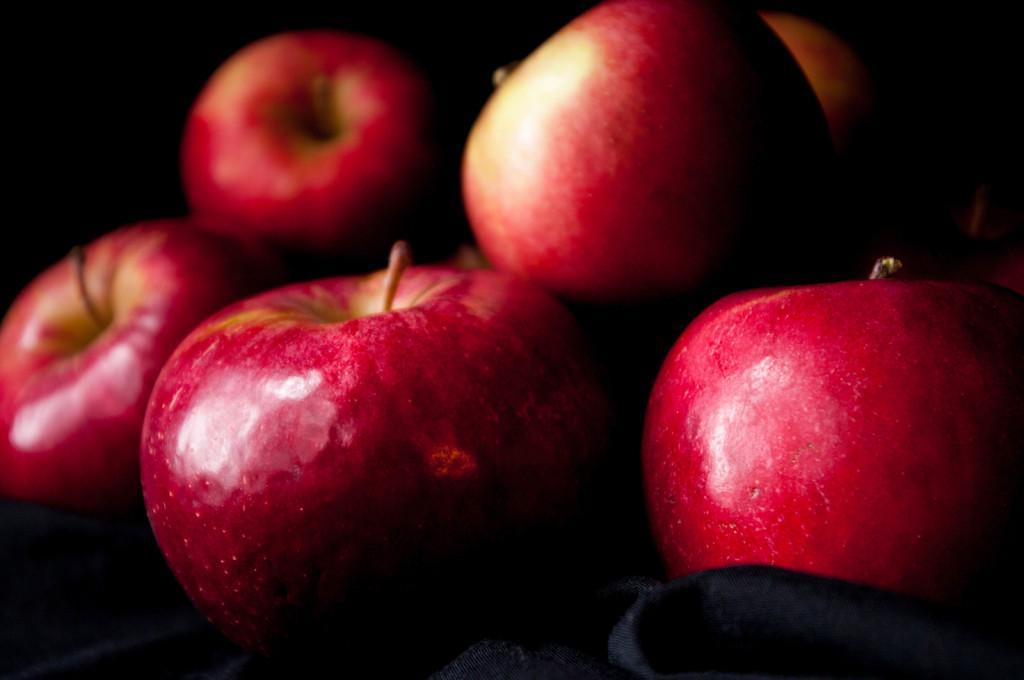Please provide a concise description of this image. In the image there are some apples and the background of the apples is dark. 